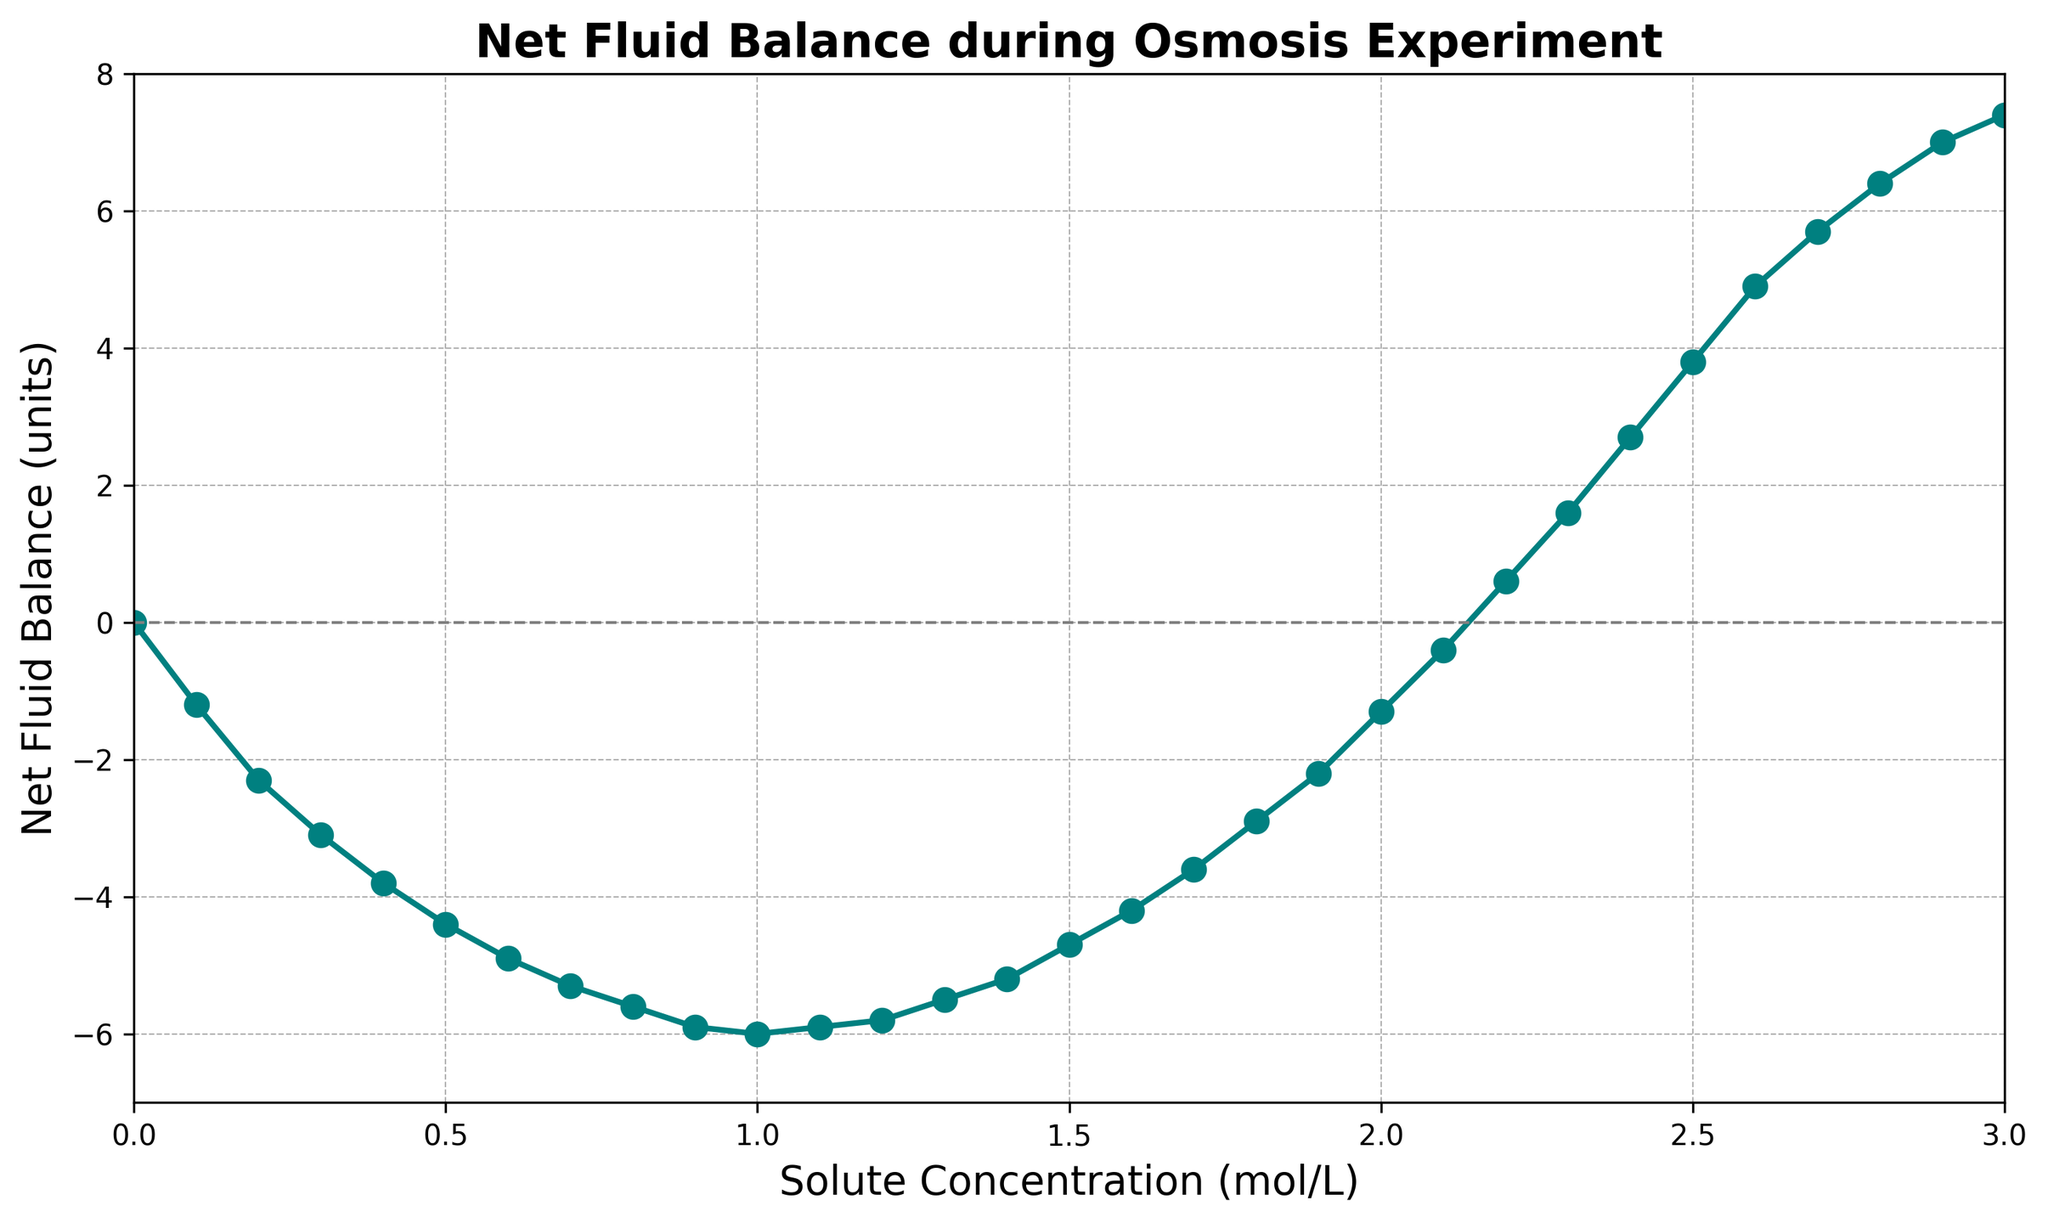What is the net fluid balance at a solute concentration of 1.0 mol/L? The data point corresponding to a solute concentration of 1.0 mol/L shows the net fluid balance. The chart indicates that at 1.0 mol/L, the net fluid balance is -6.0 units.
Answer: -6.0 units At which solute concentration does the net fluid balance first become positive? The net fluid balance becomes positive when the curve crosses the horizontal line at y = 0. This occurs at around a solute concentration of 2.2 mol/L.
Answer: 2.2 mol/L What is the maximum net fluid balance observed in this experiment? Observing the highest point on the chart, the net fluid balance reaches its maximum at the highest solute concentration value, which is 7.4 units at 3.0 mol/L.
Answer: 7.4 units Between which solute concentrations does the net fluid balance increase the most? The net fluid balance increases significantly between solute concentrations of 0.0 to 3.0 mol/L, but the dramatic increase occurs between 2.0 to 2.5 mol/L, where the net fluid balance changes from -1.3 units to 3.8 units. The calculation: 3.8 - (-1.3) = 5.1 units.
Answer: 2.0 and 2.5 mol/L At what solute concentration does the net fluid balance reach its minimum value? The lowest point on the net fluid balance curve occurs at a solute concentration of 1.0 mol/L, where the balance is -6.0 units.
Answer: 1.0 mol/L Which solute concentration results in a net fluid balance closest to zero without being zero? The data point closest to zero without being zero is observed at 2.1 mol/L with a net fluid balance of -0.4 units.
Answer: 2.1 mol/L Describe the shape of the net fluid balance curve between solute concentrations of 0.0 and 1.0 mol/L. Between 0.0 and 1.0 mol/L, the net fluid balance decreases gradually, showing a steady downward trend from 0.0 to -6.0 units.
Answer: Steady downward trend How many points on the graph have a net fluid balance below -5.0 units? By counting the data points lying below the -5.0 unit mark, there are 5 such points (0.6 mol/L to 1.0 mol/L and 1.1 mol/L).
Answer: 5 Is the net fluid balance symmetric around a particular solute concentration? The net fluid balance curve shows approximate symmetry around the 1.5 mol/L solute concentration, as the values on either side mirror each other closely.
Answer: 1.5 mol/L What happens to the net fluid balance after a solute concentration of 3.0 mol/L based on the chart? The chart only provides data up to 3.0 mol/L; hence any behavior beyond 3.0 mol/L cannot be inferred from the given chart.
Answer: Not inferable 